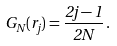Convert formula to latex. <formula><loc_0><loc_0><loc_500><loc_500>G _ { N } ( r _ { j } ) = \frac { 2 j - 1 } { 2 N } \, .</formula> 